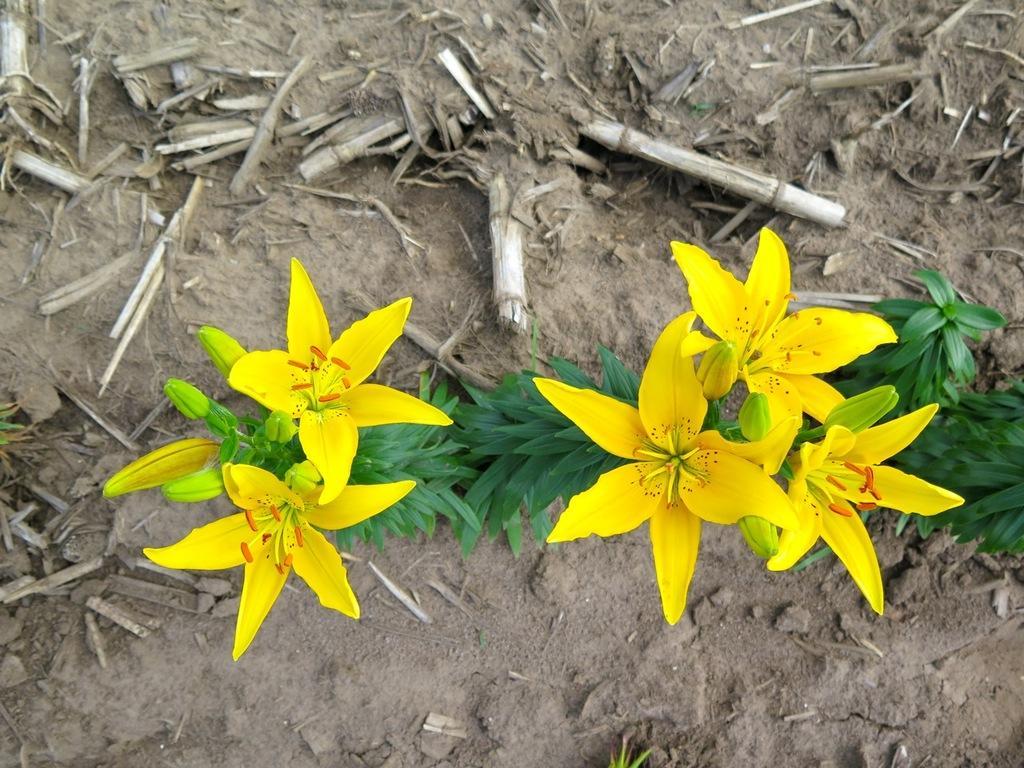How would you summarize this image in a sentence or two? In the foreground of this image, there are yellow colored flowers and buds to the plants. In the background, there are sticks on the ground. 